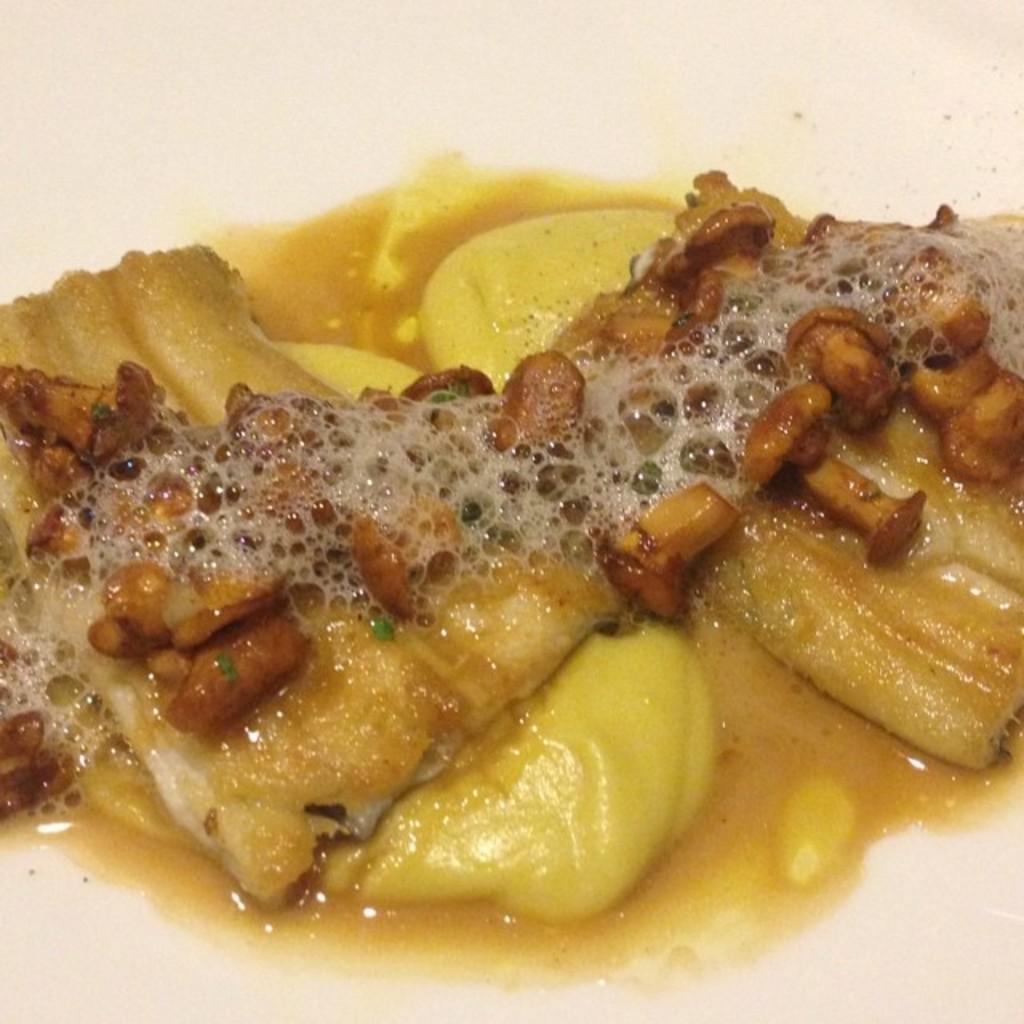How would you summarize this image in a sentence or two? In the image I can see a food item which has some liquid in it. 